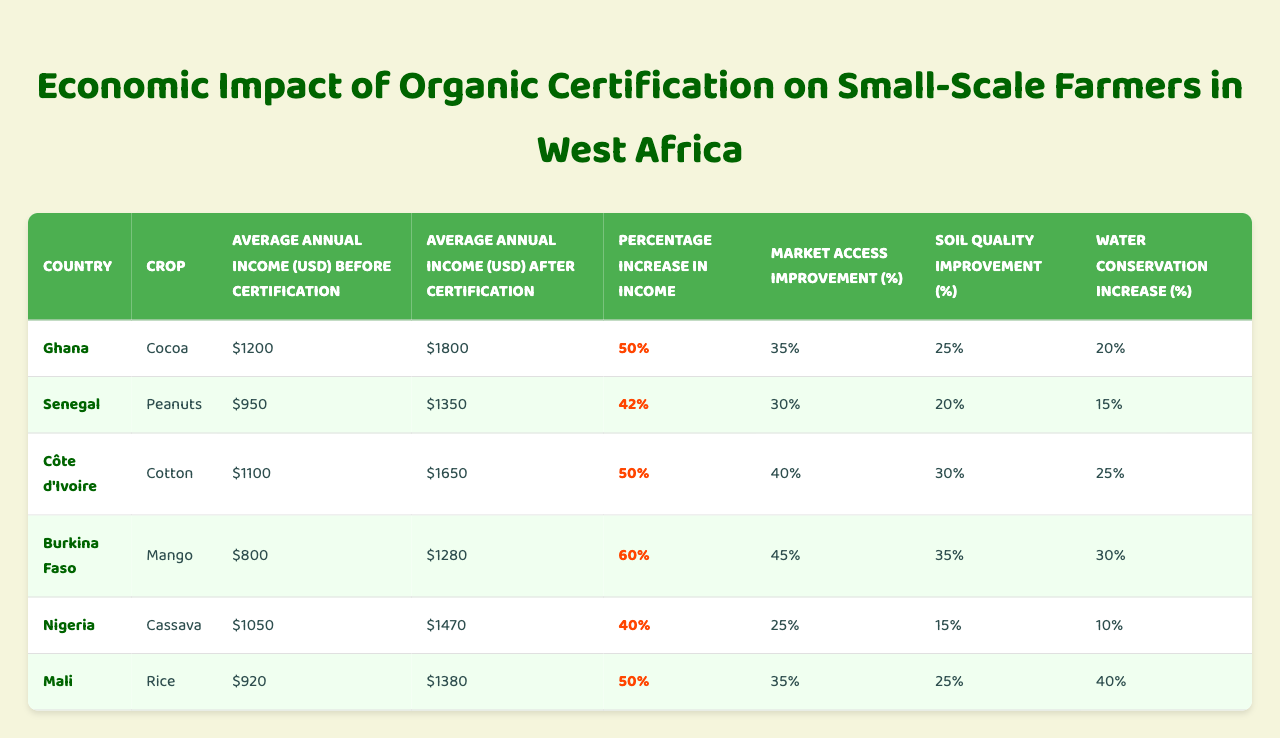What is the average annual income for cocoa farmers in Ghana after certification? The table shows that the average annual income for cocoa farmers in Ghana after certification is $1800.
Answer: $1800 What percentage increase in income did mango farmers in Burkina Faso experience after certification? According to the table, mango farmers in Burkina Faso saw a percentage increase in income of 60%.
Answer: 60% Did the average annual income for farmers in Senegal increase after certification? Yes, farmers in Senegal had an average annual income of $1350 after certification, which is higher than the $950 they earned before certification.
Answer: Yes Which country showed the highest market access improvement percentage? By comparing the market access improvement percentages in the table, Burkina Faso with 45% has the highest market access improvement.
Answer: Burkina Faso What is the average annual income for cassava farmers in Nigeria before certification? The table indicates that cassava farmers in Nigeria had an average annual income of $1050 before certification.
Answer: $1050 How much did soil quality improve for cotton farmers in Côte d'Ivoire? The table states that soil quality improved by 30% for cotton farmers in Côte d'Ivoire after certification.
Answer: 30% What is the combined percentage increase in income for cocoa farmers in Ghana and rice farmers in Mali after certification? The percentage increases in income are 50% for Ghana and 50% for Mali. Therefore, combining them: 50% + 50% = 100%.
Answer: 100% Which crop had the lowest average annual income after certification? Referring to the table, cassava in Nigeria had the lowest average annual income after certification at $1470.
Answer: Cassava What is the average water conservation increase across all crops listed? To find the average water conservation increase, sum up all the percentages (20 + 15 + 25 + 30 + 10 + 40) which equals 140%. Then divide by the number of crops (6): 140/6 = 23.33%.
Answer: 23.33% Is there a difference in percentage increase in income between mango farmers in Burkina Faso and rice farmers in Mali? Yes, mango farmers had a 60% increase whereas rice farmers had a 50% increase, a difference of 10%.
Answer: Yes, 10% difference Which country and crop combination had the greatest improvement in water conservation? The greatest improvement in water conservation was reported for rice farmers in Mali with a 40% increase.
Answer: Rice farmers in Mali 